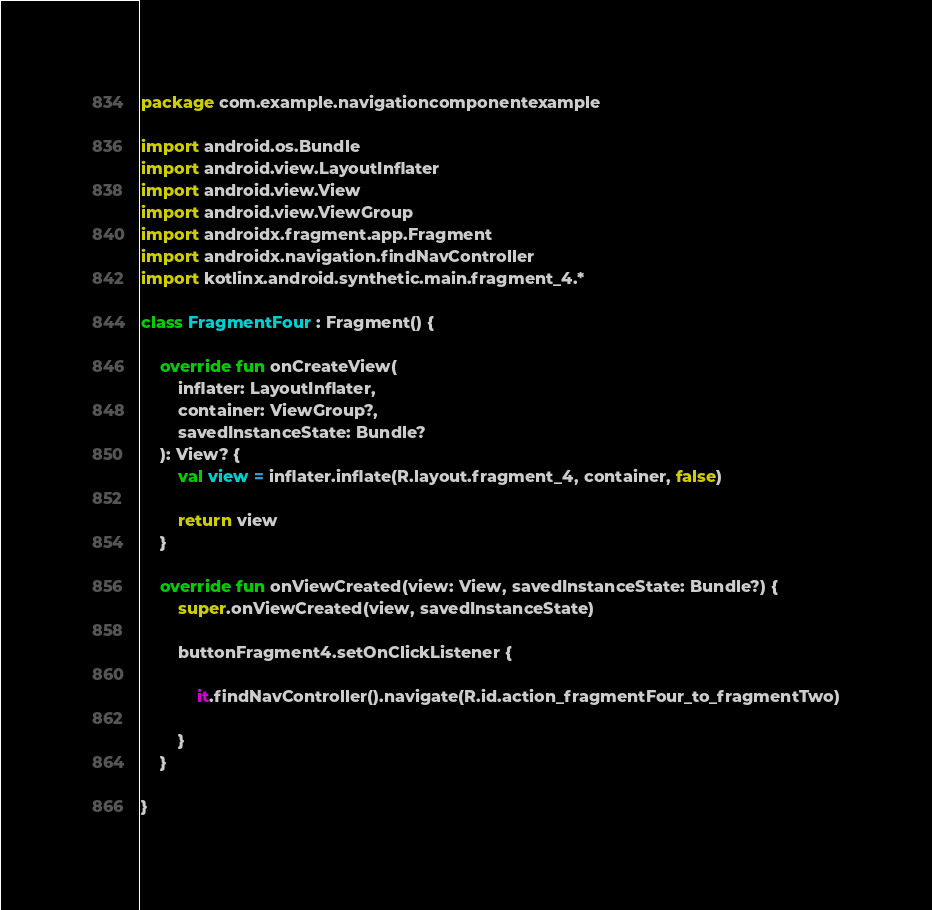Convert code to text. <code><loc_0><loc_0><loc_500><loc_500><_Kotlin_>package com.example.navigationcomponentexample

import android.os.Bundle
import android.view.LayoutInflater
import android.view.View
import android.view.ViewGroup
import androidx.fragment.app.Fragment
import androidx.navigation.findNavController
import kotlinx.android.synthetic.main.fragment_4.*

class FragmentFour : Fragment() {

    override fun onCreateView(
        inflater: LayoutInflater,
        container: ViewGroup?,
        savedInstanceState: Bundle?
    ): View? {
        val view = inflater.inflate(R.layout.fragment_4, container, false)

        return view
    }

    override fun onViewCreated(view: View, savedInstanceState: Bundle?) {
        super.onViewCreated(view, savedInstanceState)

        buttonFragment4.setOnClickListener {

            it.findNavController().navigate(R.id.action_fragmentFour_to_fragmentTwo)

        }
    }

}</code> 